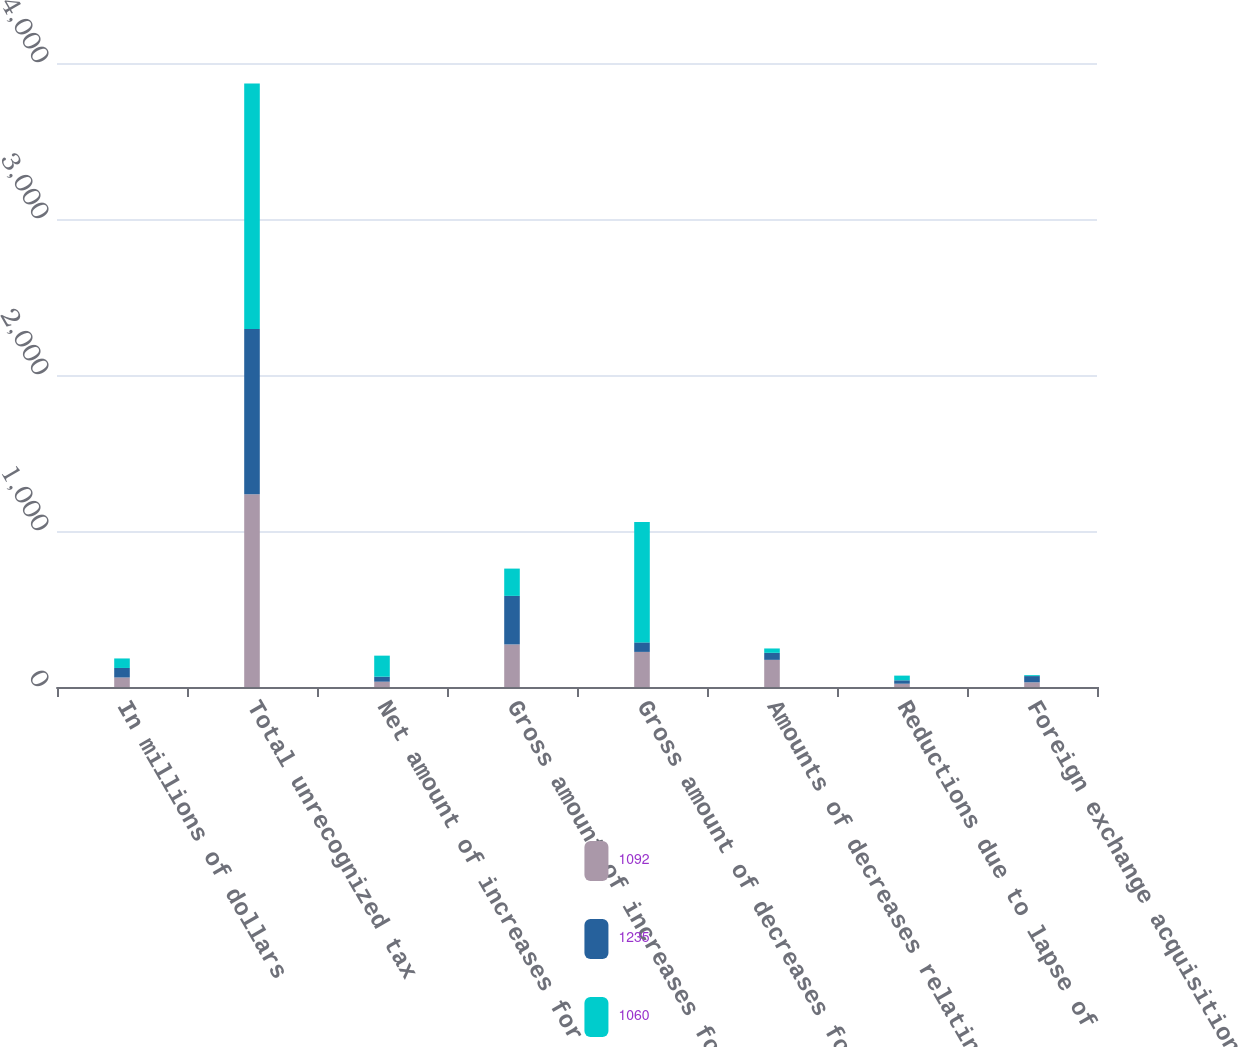Convert chart. <chart><loc_0><loc_0><loc_500><loc_500><stacked_bar_chart><ecel><fcel>In millions of dollars<fcel>Total unrecognized tax<fcel>Net amount of increases for<fcel>Gross amount of increases for<fcel>Gross amount of decreases for<fcel>Amounts of decreases relating<fcel>Reductions due to lapse of<fcel>Foreign exchange acquisitions<nl><fcel>1092<fcel>61<fcel>1235<fcel>34<fcel>273<fcel>225<fcel>174<fcel>21<fcel>30<nl><fcel>1235<fcel>61<fcel>1060<fcel>32<fcel>311<fcel>61<fcel>45<fcel>22<fcel>40<nl><fcel>1060<fcel>61<fcel>1574<fcel>135<fcel>175<fcel>772<fcel>28<fcel>30<fcel>6<nl></chart> 